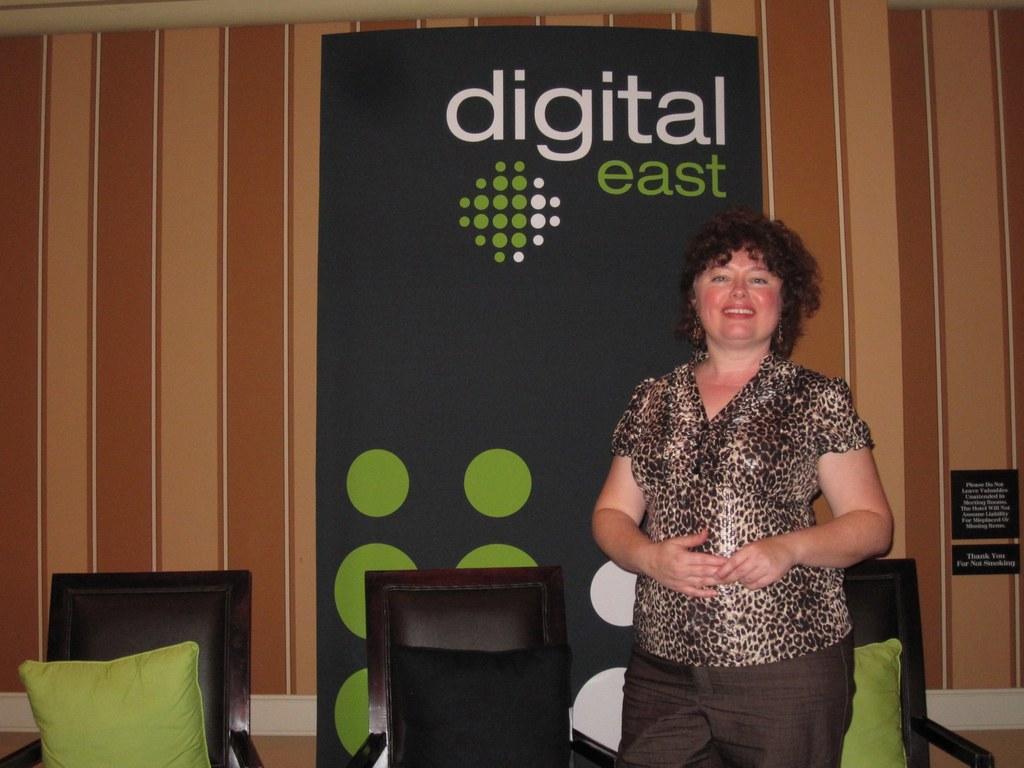How would you summarize this image in a sentence or two? In the image we can see there is a woman standing and there are chairs kept on the floor. There are cushions kept on the chairs and behind there is a banner on which its written ¨Digital East¨. 